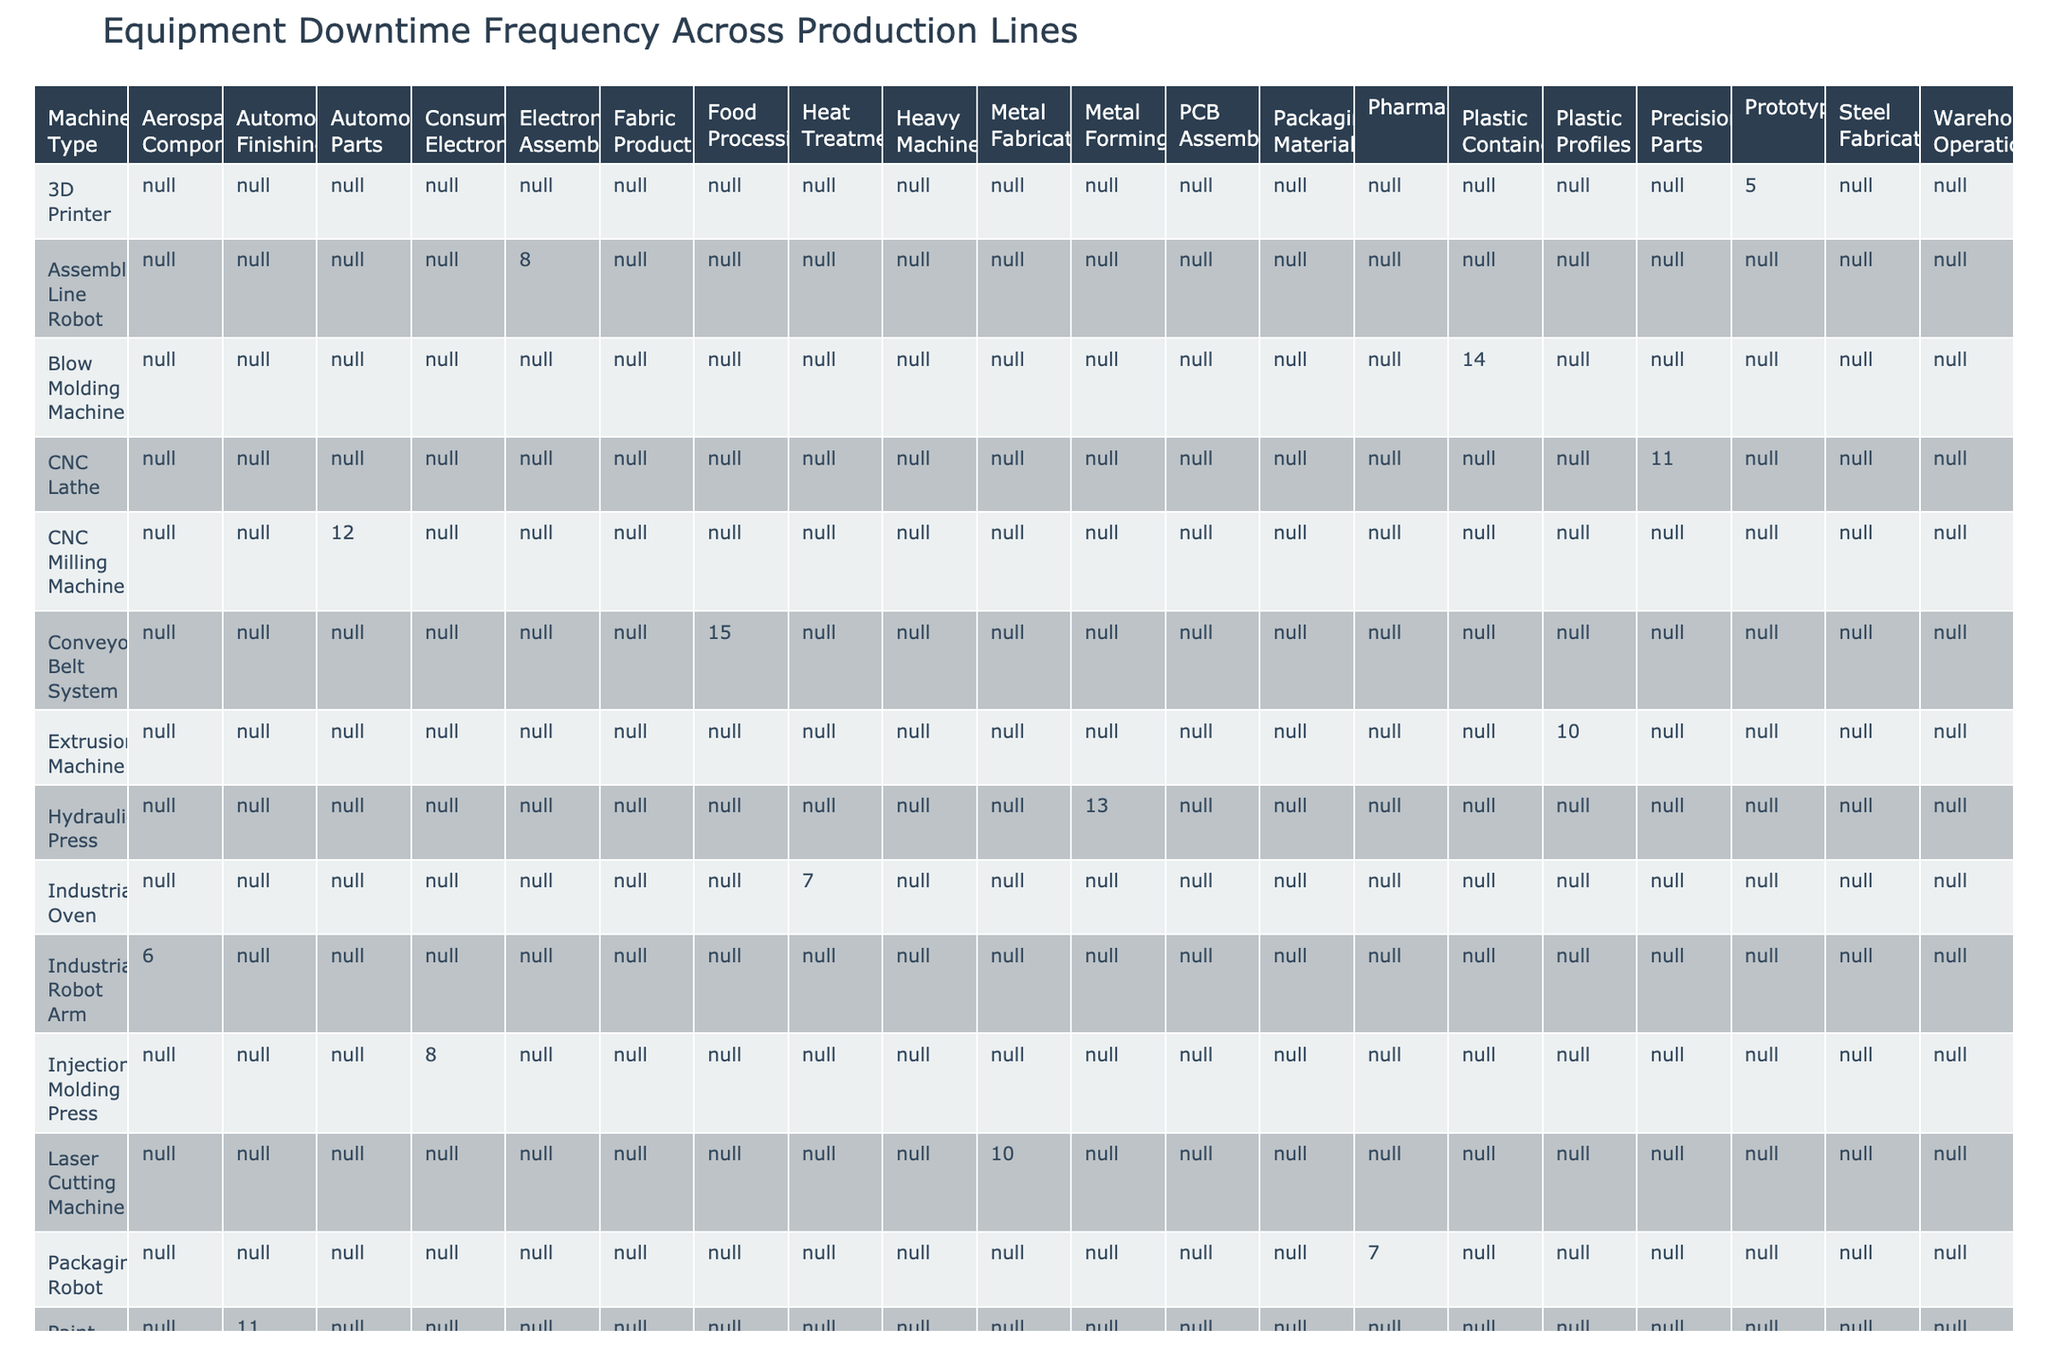What is the downtime frequency of the CNC Milling Machine? The table shows that the CNC Milling Machine has a downtime frequency of 12 hours per month.
Answer: 12 hours/month Which machine type has the highest downtime frequency? By examining the table, the Textile Loom has the highest downtime frequency of 16 hours per month.
Answer: Textile Loom What is the total downtime frequency for all machines in the Automotive sector? Summing the downtime frequencies for the Automotive Parts (12) and Automotive Finishing (11) gives 12 + 11 = 23 hours per month for the Automotive sector.
Answer: 23 hours/month Is there any machine type with a downtime frequency of less than 6 hours? Looking at the table, the 3D Printer and the Pick and Place Machine both have frequencies of 5 and 6 hours, respectively. Therefore, no machine has a frequency of less than 6 hours.
Answer: No What is the average downtime frequency for all machines listed in the Food Processing sector? The total downtime frequency for the Food Processing sector is only represented by the Conveyor Belt System, which has a downtime frequency of 15 hours per month. Since there's only one machine, the average is still 15 hours per month.
Answer: 15 hours/month Which production line has more machines associated with it: Aerospace Components or Consumer Electronics? The Aerospace Components production line has 1 machine (Industrial Robot Arm), while the Consumer Electronics line has 1 machine (Injection Molding Press). Therefore, they are equal.
Answer: Equal What is the total downtime frequency for machines categorized under Robotics? For the Robotics category, we have the Industrial Robot Arm (6), Packaging Robot (7), Welding Robot (9), 3D Printer (5), and Robotic Palletizer (8). Adding these gives 6 + 7 + 9 + 5 + 8 = 35 hours per month.
Answer: 35 hours/month How many machine types have a downtime frequency greater than 10 hours? By reviewing the table, the machines with frequencies greater than 10 hours are: Conveyor Belt System (15), Blow Molding Machine (14), Hydraulic Press (13), CNC Milling Machine (12), Paint Spray Booth (11), and CNC Lathe (11), resulting in a count of 6 machines.
Answer: 6 machines What is the cumulative downtime frequency for all machines in the Pharmaceutical sector? The Pharmaceutical sector has one machine, the Packaging Robot, which has a downtime frequency of 7 hours per month, making the cumulative frequency 7 hours.
Answer: 7 hours/month If we consider only the machines in the Electronics sector, what is their average downtime frequency? The Electronics sector includes the Injection Molding Press (8), Assembly Line Robot (8), and Printing Press (12). Summing these gives 8 + 8 + 12 = 28 hours, then dividing by 3 (the number of machines) gives an average of approximately 9.33 hours/month.
Answer: 9.33 hours/month 